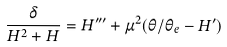<formula> <loc_0><loc_0><loc_500><loc_500>\frac { \delta } { H ^ { 2 } + H } = H ^ { \prime \prime \prime } + \mu ^ { 2 } ( \theta / \theta _ { e } - H ^ { \prime } )</formula> 